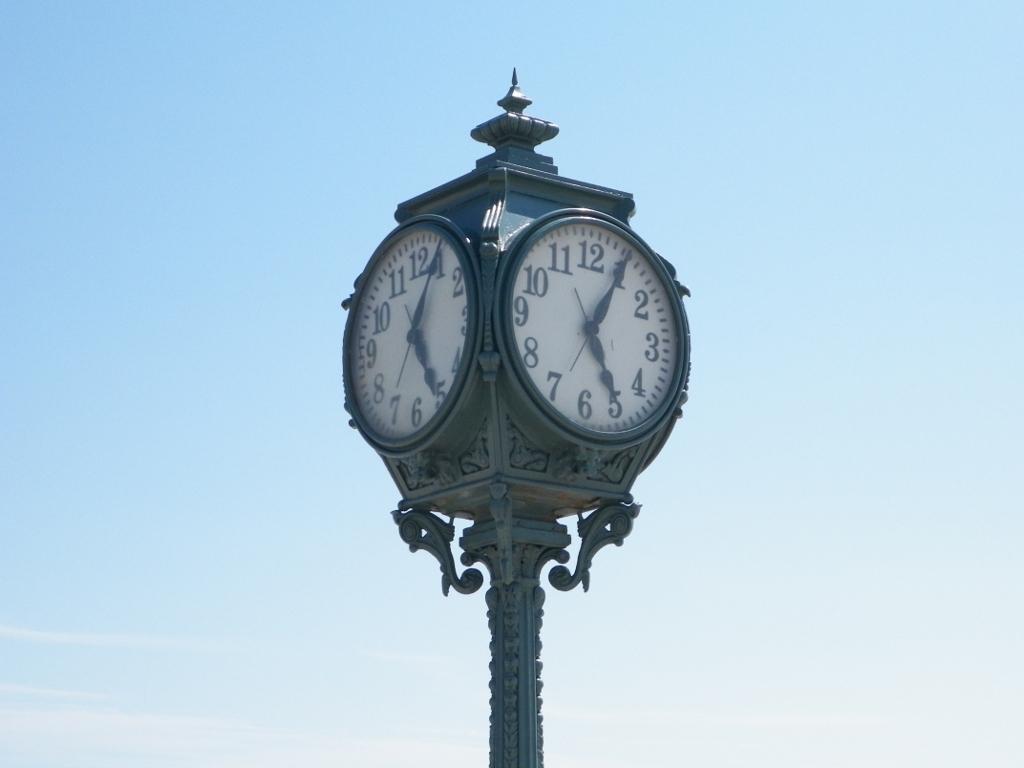What time is shown on the clock?
Offer a terse response. 5:05. 